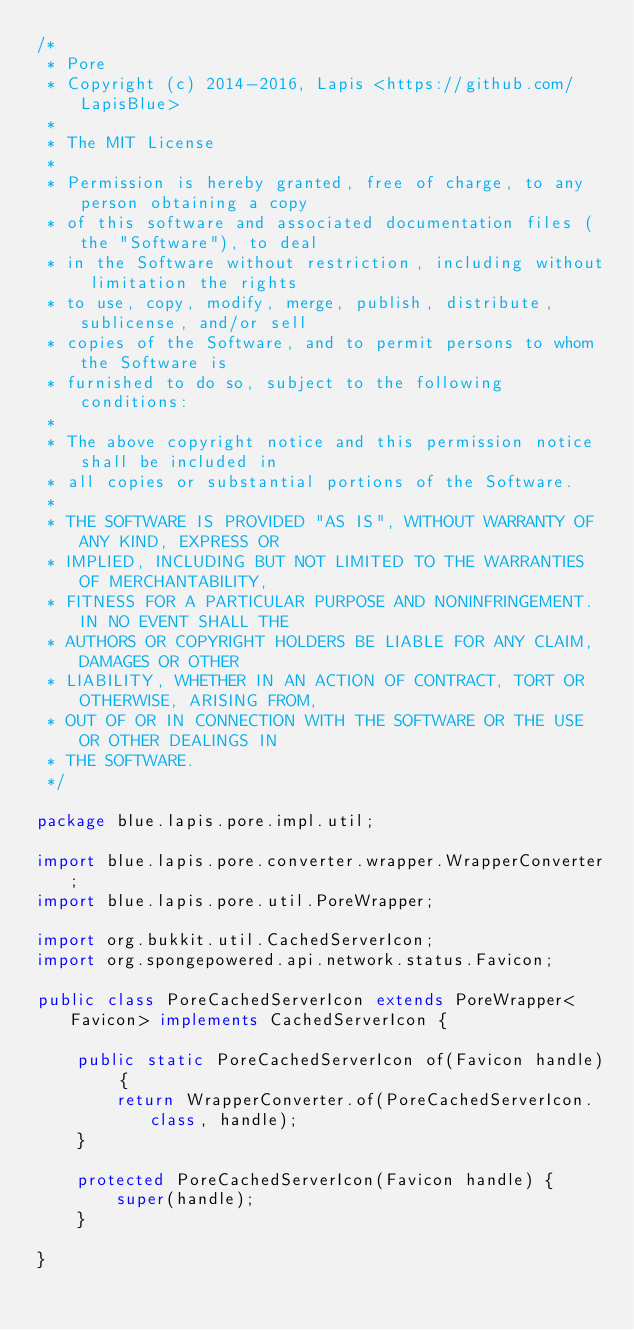<code> <loc_0><loc_0><loc_500><loc_500><_Java_>/*
 * Pore
 * Copyright (c) 2014-2016, Lapis <https://github.com/LapisBlue>
 *
 * The MIT License
 *
 * Permission is hereby granted, free of charge, to any person obtaining a copy
 * of this software and associated documentation files (the "Software"), to deal
 * in the Software without restriction, including without limitation the rights
 * to use, copy, modify, merge, publish, distribute, sublicense, and/or sell
 * copies of the Software, and to permit persons to whom the Software is
 * furnished to do so, subject to the following conditions:
 *
 * The above copyright notice and this permission notice shall be included in
 * all copies or substantial portions of the Software.
 *
 * THE SOFTWARE IS PROVIDED "AS IS", WITHOUT WARRANTY OF ANY KIND, EXPRESS OR
 * IMPLIED, INCLUDING BUT NOT LIMITED TO THE WARRANTIES OF MERCHANTABILITY,
 * FITNESS FOR A PARTICULAR PURPOSE AND NONINFRINGEMENT. IN NO EVENT SHALL THE
 * AUTHORS OR COPYRIGHT HOLDERS BE LIABLE FOR ANY CLAIM, DAMAGES OR OTHER
 * LIABILITY, WHETHER IN AN ACTION OF CONTRACT, TORT OR OTHERWISE, ARISING FROM,
 * OUT OF OR IN CONNECTION WITH THE SOFTWARE OR THE USE OR OTHER DEALINGS IN
 * THE SOFTWARE.
 */

package blue.lapis.pore.impl.util;

import blue.lapis.pore.converter.wrapper.WrapperConverter;
import blue.lapis.pore.util.PoreWrapper;

import org.bukkit.util.CachedServerIcon;
import org.spongepowered.api.network.status.Favicon;

public class PoreCachedServerIcon extends PoreWrapper<Favicon> implements CachedServerIcon {

    public static PoreCachedServerIcon of(Favicon handle) {
        return WrapperConverter.of(PoreCachedServerIcon.class, handle);
    }

    protected PoreCachedServerIcon(Favicon handle) {
        super(handle);
    }

}
</code> 